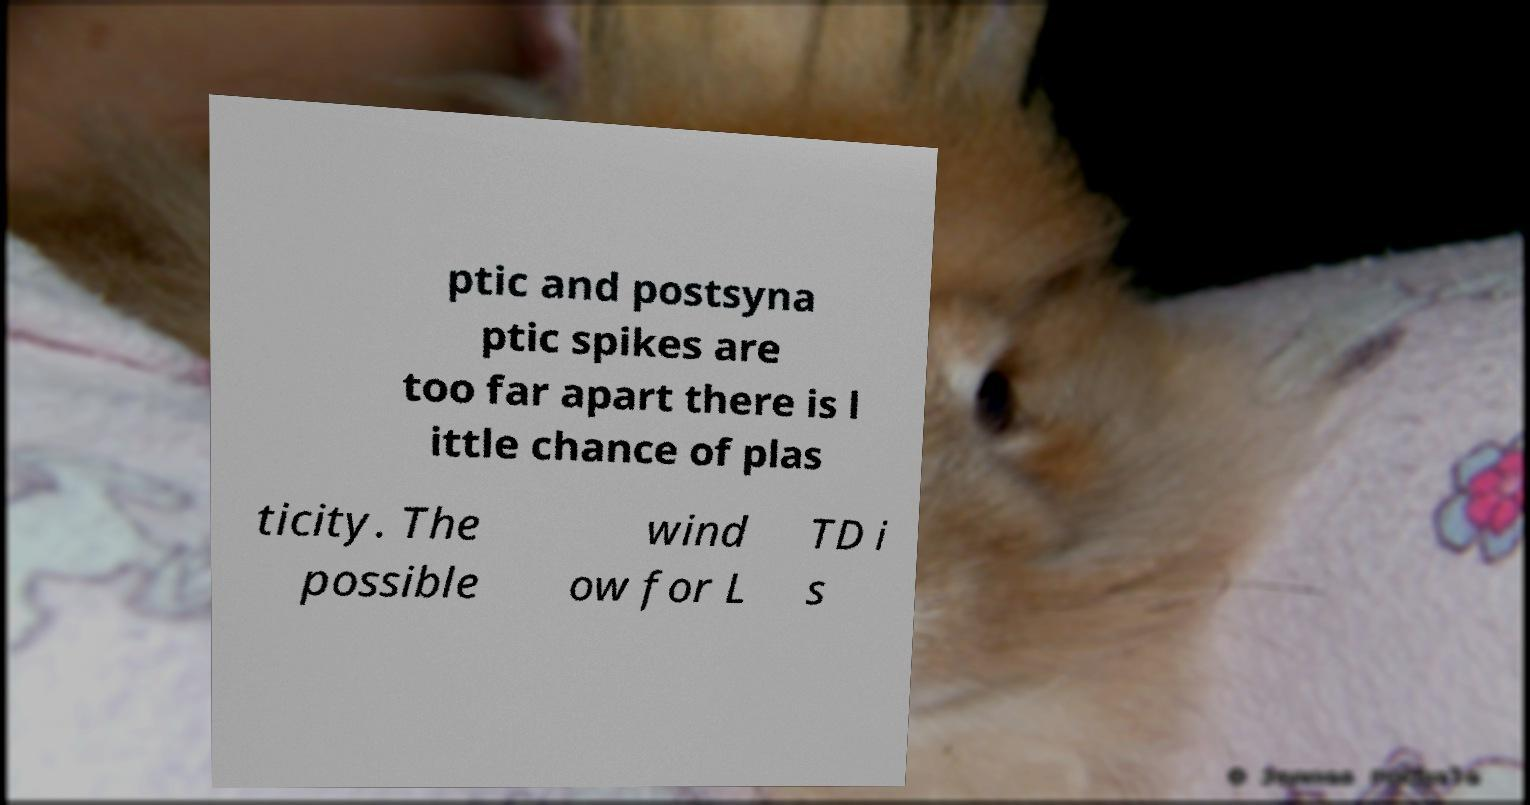Please read and relay the text visible in this image. What does it say? ptic and postsyna ptic spikes are too far apart there is l ittle chance of plas ticity. The possible wind ow for L TD i s 